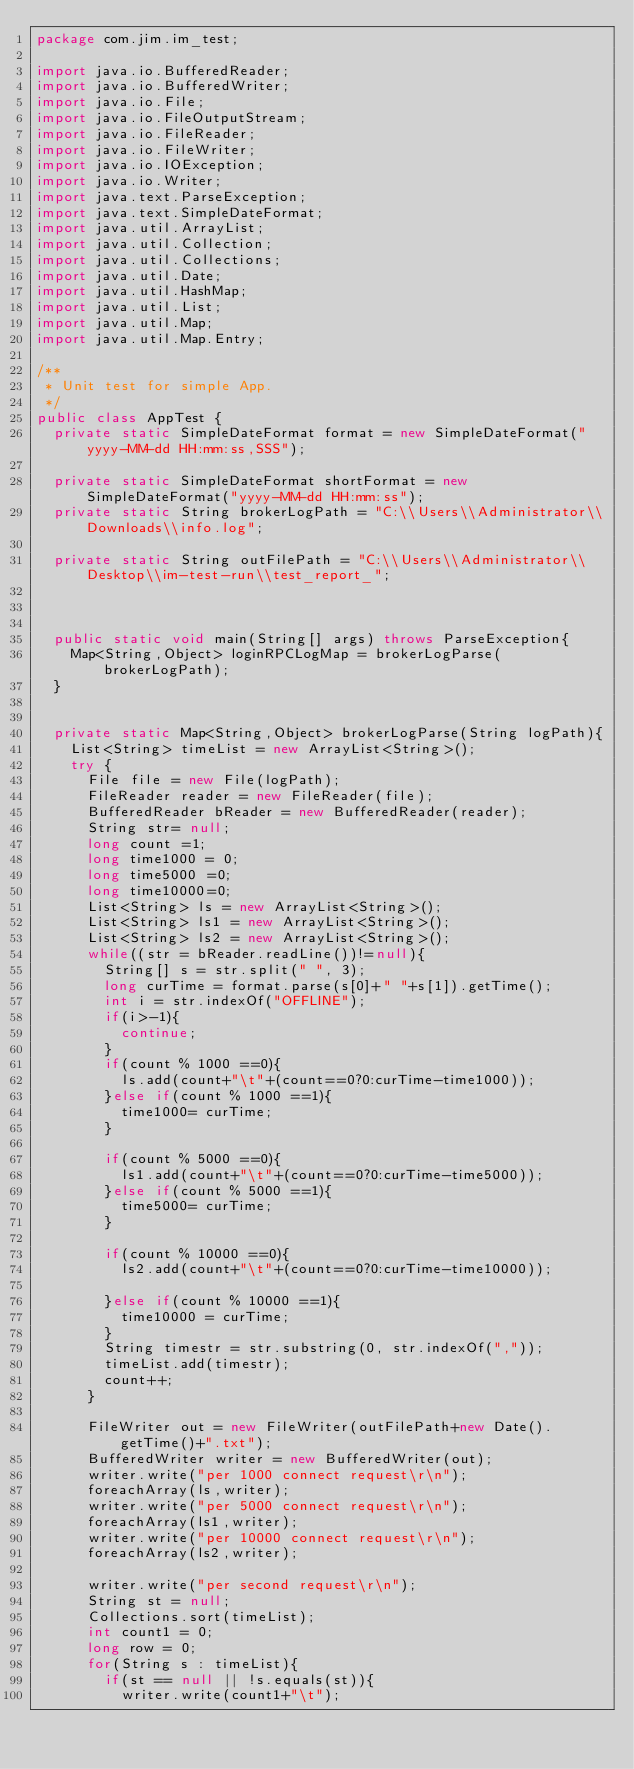<code> <loc_0><loc_0><loc_500><loc_500><_Java_>package com.jim.im_test;

import java.io.BufferedReader;
import java.io.BufferedWriter;
import java.io.File;
import java.io.FileOutputStream;
import java.io.FileReader;
import java.io.FileWriter;
import java.io.IOException;
import java.io.Writer;
import java.text.ParseException;
import java.text.SimpleDateFormat;
import java.util.ArrayList;
import java.util.Collection;
import java.util.Collections;
import java.util.Date;
import java.util.HashMap;
import java.util.List;
import java.util.Map;
import java.util.Map.Entry;

/**
 * Unit test for simple App.
 */
public class AppTest {
	private static SimpleDateFormat format = new SimpleDateFormat("yyyy-MM-dd HH:mm:ss,SSS");
	
	private static SimpleDateFormat shortFormat = new SimpleDateFormat("yyyy-MM-dd HH:mm:ss");
	private static String brokerLogPath = "C:\\Users\\Administrator\\Downloads\\info.log";
	
	private static String outFilePath = "C:\\Users\\Administrator\\Desktop\\im-test-run\\test_report_";
	
	
	
	public static void main(String[] args) throws ParseException{
		Map<String,Object> loginRPCLogMap = brokerLogParse(brokerLogPath);
	}
	
	
	private static Map<String,Object> brokerLogParse(String logPath){
		List<String> timeList = new ArrayList<String>();
		try {
			File file = new File(logPath);
			FileReader reader = new FileReader(file);
			BufferedReader bReader = new BufferedReader(reader);
			String str= null;
			long count =1;
			long time1000 = 0;
			long time5000 =0;
			long time10000=0;
			List<String> ls = new ArrayList<String>();
			List<String> ls1 = new ArrayList<String>();
			List<String> ls2 = new ArrayList<String>();
			while((str = bReader.readLine())!=null){
				String[] s = str.split(" ", 3);
				long curTime = format.parse(s[0]+" "+s[1]).getTime();
				int i = str.indexOf("OFFLINE");
				if(i>-1){
					continue;
				}
				if(count % 1000 ==0){
					ls.add(count+"\t"+(count==0?0:curTime-time1000));
				}else if(count % 1000 ==1){
					time1000= curTime;
				}
				
				if(count % 5000 ==0){
					ls1.add(count+"\t"+(count==0?0:curTime-time5000));
				}else if(count % 5000 ==1){
					time5000= curTime;
				}
				
				if(count % 10000 ==0){
					ls2.add(count+"\t"+(count==0?0:curTime-time10000));
					
				}else if(count % 10000 ==1){
					time10000 = curTime;
				}
				String timestr = str.substring(0, str.indexOf(","));
				timeList.add(timestr);
				count++;
			}
			
			FileWriter out = new FileWriter(outFilePath+new Date().getTime()+".txt");
			BufferedWriter writer = new BufferedWriter(out);
			writer.write("per 1000 connect request\r\n");
			foreachArray(ls,writer);
			writer.write("per 5000 connect request\r\n");
			foreachArray(ls1,writer);
			writer.write("per 10000 connect request\r\n");
			foreachArray(ls2,writer);
			
			writer.write("per second request\r\n");
			String st = null;
			Collections.sort(timeList);
			int count1 = 0;
			long row = 0;
			for(String s : timeList){
				if(st == null || !s.equals(st)){
					writer.write(count1+"\t");</code> 